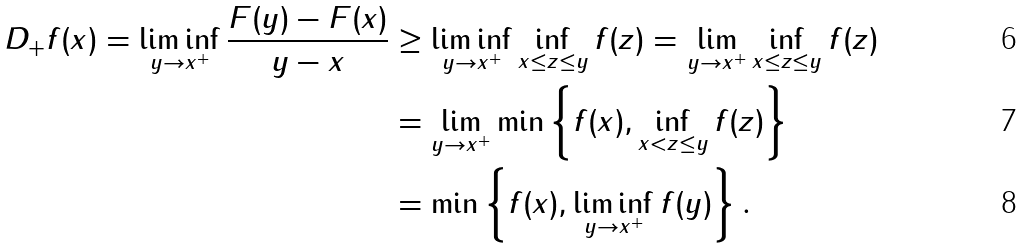Convert formula to latex. <formula><loc_0><loc_0><loc_500><loc_500>D _ { + } f ( x ) = \liminf _ { y \to x ^ { + } } \frac { F ( y ) - F ( x ) } { y - x } & \geq \liminf _ { y \to x ^ { + } } \inf _ { x \leq z \leq y } f ( z ) = \lim _ { y \to x ^ { + } } \inf _ { x \leq z \leq y } f ( z ) \\ & = \lim _ { y \to x ^ { + } } \min \left \{ f ( x ) , \inf _ { x < z \leq y } f ( z ) \right \} \\ & = \min \left \{ f ( x ) , \liminf _ { y \to x ^ { + } } f ( y ) \right \} .</formula> 